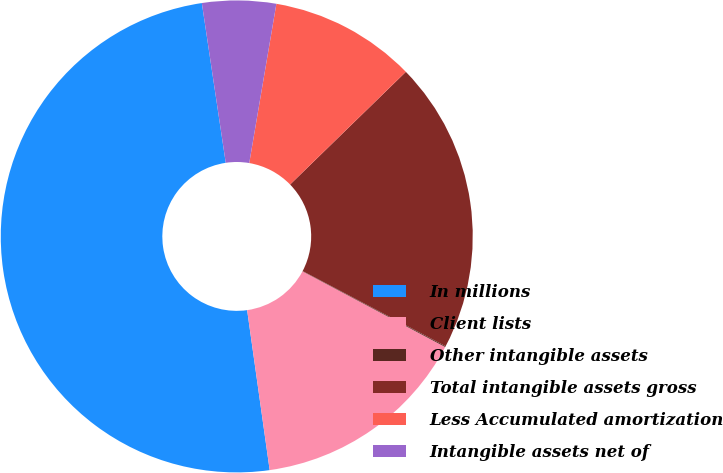Convert chart. <chart><loc_0><loc_0><loc_500><loc_500><pie_chart><fcel>In millions<fcel>Client lists<fcel>Other intangible assets<fcel>Total intangible assets gross<fcel>Less Accumulated amortization<fcel>Intangible assets net of<nl><fcel>49.87%<fcel>15.01%<fcel>0.06%<fcel>19.99%<fcel>10.03%<fcel>5.05%<nl></chart> 